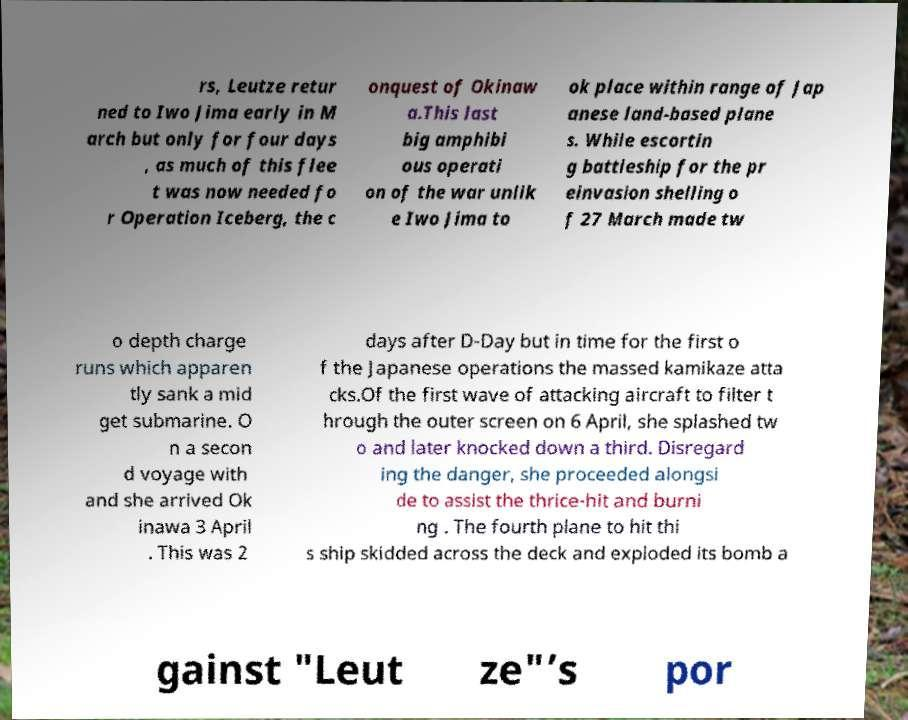Can you accurately transcribe the text from the provided image for me? rs, Leutze retur ned to Iwo Jima early in M arch but only for four days , as much of this flee t was now needed fo r Operation Iceberg, the c onquest of Okinaw a.This last big amphibi ous operati on of the war unlik e Iwo Jima to ok place within range of Jap anese land-based plane s. While escortin g battleship for the pr einvasion shelling o f 27 March made tw o depth charge runs which apparen tly sank a mid get submarine. O n a secon d voyage with and she arrived Ok inawa 3 April . This was 2 days after D-Day but in time for the first o f the Japanese operations the massed kamikaze atta cks.Of the first wave of attacking aircraft to filter t hrough the outer screen on 6 April, she splashed tw o and later knocked down a third. Disregard ing the danger, she proceeded alongsi de to assist the thrice-hit and burni ng . The fourth plane to hit thi s ship skidded across the deck and exploded its bomb a gainst "Leut ze"’s por 